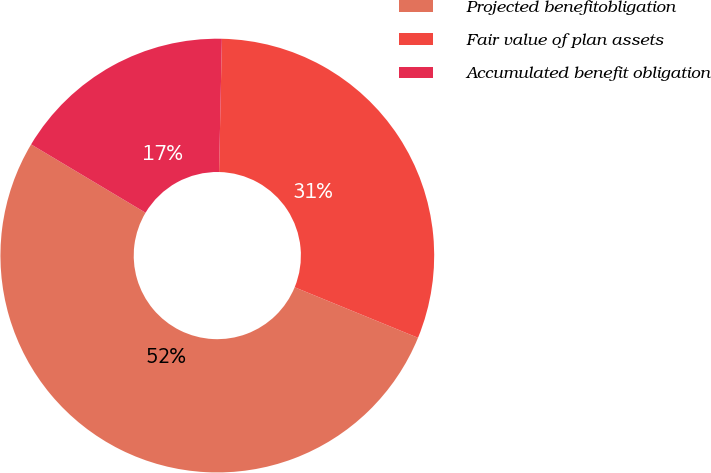Convert chart. <chart><loc_0><loc_0><loc_500><loc_500><pie_chart><fcel>Projected benefitobligation<fcel>Fair value of plan assets<fcel>Accumulated benefit obligation<nl><fcel>52.38%<fcel>30.85%<fcel>16.77%<nl></chart> 